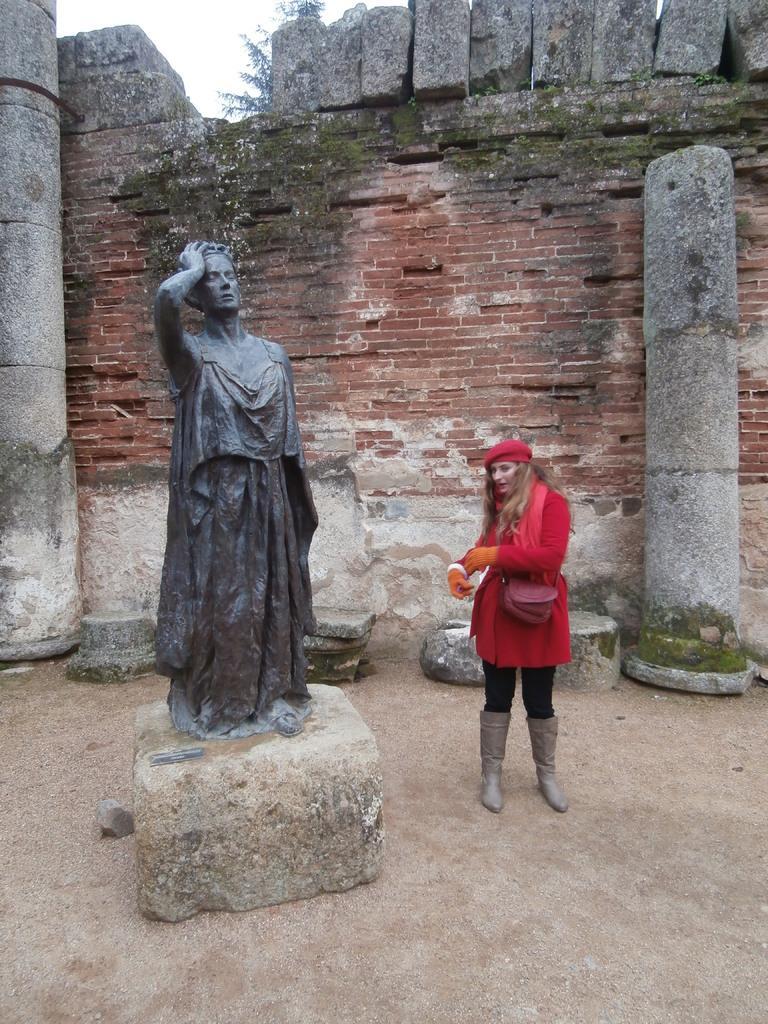Can you describe this image briefly? On the left there is a sculpture. Towards right we can see a woman in red dress standing. At the top it is ground. In the middle we can see an old construction. In the background we can see tree and sky. 